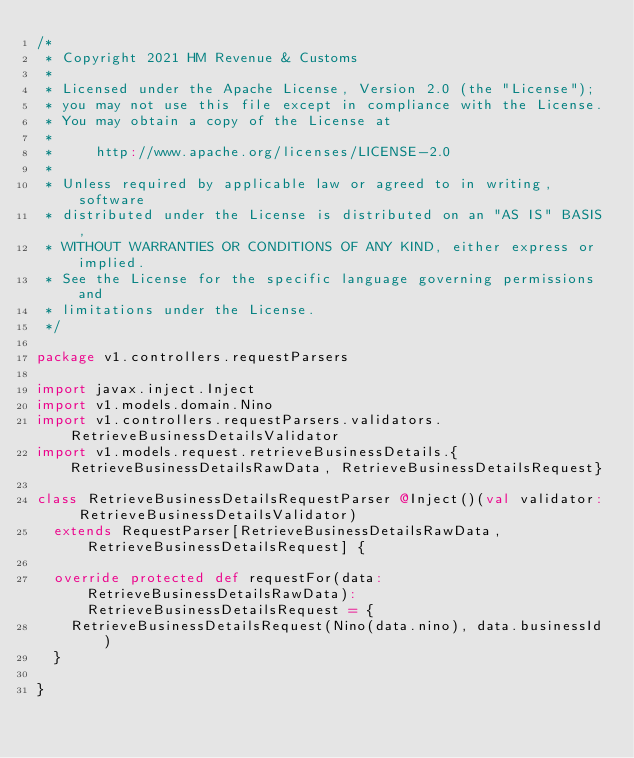Convert code to text. <code><loc_0><loc_0><loc_500><loc_500><_Scala_>/*
 * Copyright 2021 HM Revenue & Customs
 *
 * Licensed under the Apache License, Version 2.0 (the "License");
 * you may not use this file except in compliance with the License.
 * You may obtain a copy of the License at
 *
 *     http://www.apache.org/licenses/LICENSE-2.0
 *
 * Unless required by applicable law or agreed to in writing, software
 * distributed under the License is distributed on an "AS IS" BASIS,
 * WITHOUT WARRANTIES OR CONDITIONS OF ANY KIND, either express or implied.
 * See the License for the specific language governing permissions and
 * limitations under the License.
 */

package v1.controllers.requestParsers

import javax.inject.Inject
import v1.models.domain.Nino
import v1.controllers.requestParsers.validators.RetrieveBusinessDetailsValidator
import v1.models.request.retrieveBusinessDetails.{RetrieveBusinessDetailsRawData, RetrieveBusinessDetailsRequest}

class RetrieveBusinessDetailsRequestParser @Inject()(val validator: RetrieveBusinessDetailsValidator)
  extends RequestParser[RetrieveBusinessDetailsRawData, RetrieveBusinessDetailsRequest] {

  override protected def requestFor(data: RetrieveBusinessDetailsRawData): RetrieveBusinessDetailsRequest = {
    RetrieveBusinessDetailsRequest(Nino(data.nino), data.businessId)
  }

}
</code> 